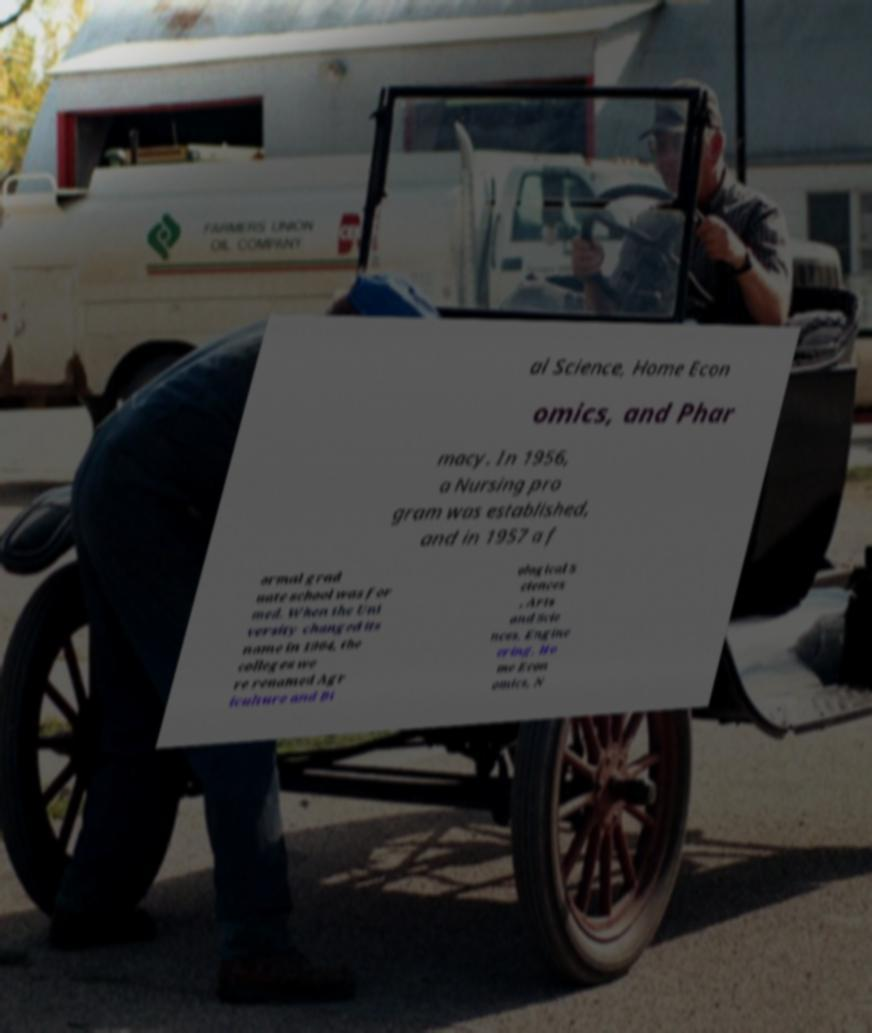Could you assist in decoding the text presented in this image and type it out clearly? al Science, Home Econ omics, and Phar macy. In 1956, a Nursing pro gram was established, and in 1957 a f ormal grad uate school was for med. When the Uni versity changed its name in 1964, the colleges we re renamed Agr iculture and Bi ological S ciences , Arts and Scie nces, Engine ering, Ho me Econ omics, N 